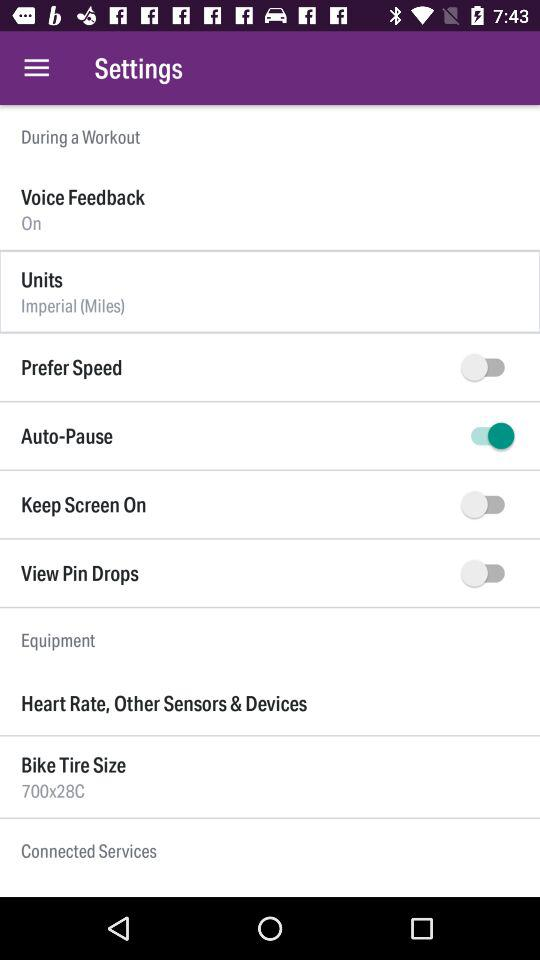What is the setting for "Voice Feedback"? The "Voice Feedback" setting is "On". 